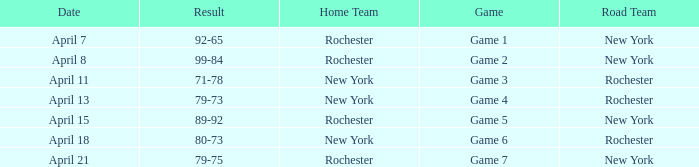Parse the full table. {'header': ['Date', 'Result', 'Home Team', 'Game', 'Road Team'], 'rows': [['April 7', '92-65', 'Rochester', 'Game 1', 'New York'], ['April 8', '99-84', 'Rochester', 'Game 2', 'New York'], ['April 11', '71-78', 'New York', 'Game 3', 'Rochester'], ['April 13', '79-73', 'New York', 'Game 4', 'Rochester'], ['April 15', '89-92', 'Rochester', 'Game 5', 'New York'], ['April 18', '80-73', 'New York', 'Game 6', 'Rochester'], ['April 21', '79-75', 'Rochester', 'Game 7', 'New York']]} Which Road Team has a Home Team of rochester, and a Result of 89-92? New York. 